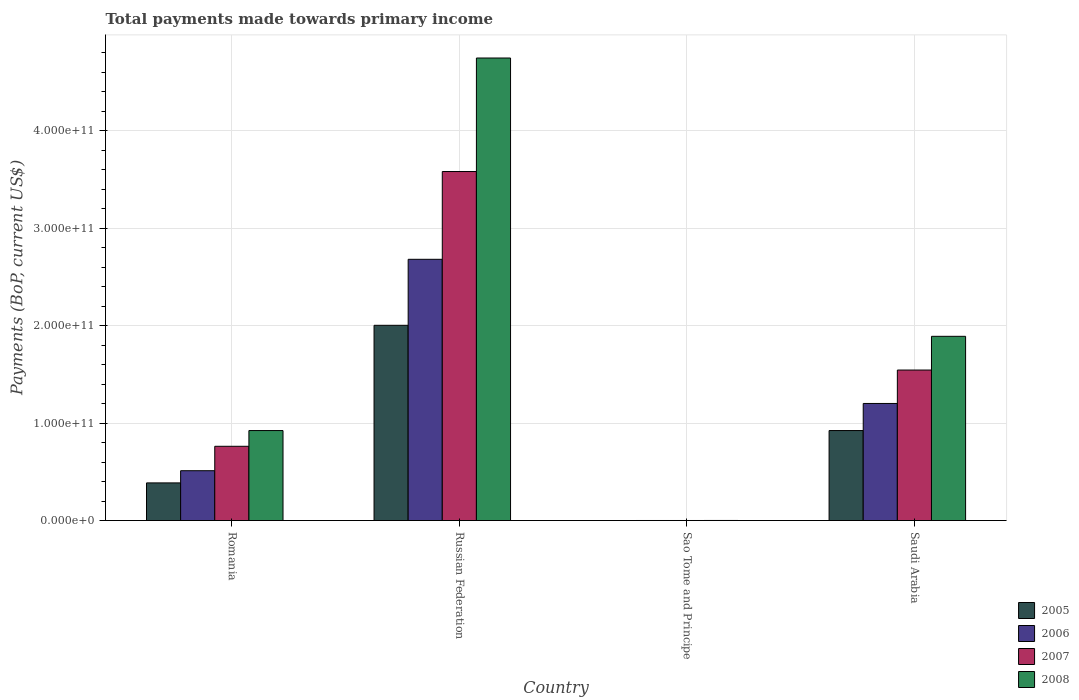Are the number of bars per tick equal to the number of legend labels?
Provide a succinct answer. Yes. Are the number of bars on each tick of the X-axis equal?
Make the answer very short. Yes. What is the label of the 3rd group of bars from the left?
Provide a succinct answer. Sao Tome and Principe. What is the total payments made towards primary income in 2006 in Russian Federation?
Ensure brevity in your answer.  2.68e+11. Across all countries, what is the maximum total payments made towards primary income in 2008?
Keep it short and to the point. 4.75e+11. Across all countries, what is the minimum total payments made towards primary income in 2005?
Your answer should be very brief. 5.76e+07. In which country was the total payments made towards primary income in 2005 maximum?
Your response must be concise. Russian Federation. In which country was the total payments made towards primary income in 2008 minimum?
Make the answer very short. Sao Tome and Principe. What is the total total payments made towards primary income in 2007 in the graph?
Provide a short and direct response. 5.89e+11. What is the difference between the total payments made towards primary income in 2005 in Russian Federation and that in Saudi Arabia?
Give a very brief answer. 1.08e+11. What is the difference between the total payments made towards primary income in 2008 in Sao Tome and Principe and the total payments made towards primary income in 2006 in Russian Federation?
Your answer should be very brief. -2.68e+11. What is the average total payments made towards primary income in 2008 per country?
Your answer should be compact. 1.89e+11. What is the difference between the total payments made towards primary income of/in 2005 and total payments made towards primary income of/in 2008 in Russian Federation?
Your response must be concise. -2.74e+11. In how many countries, is the total payments made towards primary income in 2005 greater than 40000000000 US$?
Your response must be concise. 2. What is the ratio of the total payments made towards primary income in 2005 in Romania to that in Russian Federation?
Provide a succinct answer. 0.19. What is the difference between the highest and the second highest total payments made towards primary income in 2007?
Offer a very short reply. 2.04e+11. What is the difference between the highest and the lowest total payments made towards primary income in 2005?
Keep it short and to the point. 2.00e+11. In how many countries, is the total payments made towards primary income in 2007 greater than the average total payments made towards primary income in 2007 taken over all countries?
Provide a succinct answer. 2. Is the sum of the total payments made towards primary income in 2006 in Romania and Russian Federation greater than the maximum total payments made towards primary income in 2008 across all countries?
Offer a very short reply. No. What does the 2nd bar from the left in Russian Federation represents?
Make the answer very short. 2006. What does the 1st bar from the right in Saudi Arabia represents?
Give a very brief answer. 2008. Is it the case that in every country, the sum of the total payments made towards primary income in 2006 and total payments made towards primary income in 2008 is greater than the total payments made towards primary income in 2005?
Offer a very short reply. Yes. Are all the bars in the graph horizontal?
Provide a succinct answer. No. How many countries are there in the graph?
Your answer should be compact. 4. What is the difference between two consecutive major ticks on the Y-axis?
Ensure brevity in your answer.  1.00e+11. Where does the legend appear in the graph?
Offer a terse response. Bottom right. How many legend labels are there?
Ensure brevity in your answer.  4. How are the legend labels stacked?
Offer a terse response. Vertical. What is the title of the graph?
Keep it short and to the point. Total payments made towards primary income. Does "2004" appear as one of the legend labels in the graph?
Your answer should be compact. No. What is the label or title of the X-axis?
Your answer should be very brief. Country. What is the label or title of the Y-axis?
Keep it short and to the point. Payments (BoP, current US$). What is the Payments (BoP, current US$) of 2005 in Romania?
Offer a terse response. 3.86e+1. What is the Payments (BoP, current US$) of 2006 in Romania?
Your answer should be very brief. 5.11e+1. What is the Payments (BoP, current US$) in 2007 in Romania?
Provide a succinct answer. 7.62e+1. What is the Payments (BoP, current US$) of 2008 in Romania?
Ensure brevity in your answer.  9.23e+1. What is the Payments (BoP, current US$) of 2005 in Russian Federation?
Your answer should be compact. 2.00e+11. What is the Payments (BoP, current US$) of 2006 in Russian Federation?
Provide a succinct answer. 2.68e+11. What is the Payments (BoP, current US$) in 2007 in Russian Federation?
Provide a succinct answer. 3.58e+11. What is the Payments (BoP, current US$) of 2008 in Russian Federation?
Offer a terse response. 4.75e+11. What is the Payments (BoP, current US$) of 2005 in Sao Tome and Principe?
Make the answer very short. 5.76e+07. What is the Payments (BoP, current US$) in 2006 in Sao Tome and Principe?
Make the answer very short. 8.01e+07. What is the Payments (BoP, current US$) in 2007 in Sao Tome and Principe?
Your answer should be compact. 8.58e+07. What is the Payments (BoP, current US$) in 2008 in Sao Tome and Principe?
Your answer should be very brief. 1.16e+08. What is the Payments (BoP, current US$) in 2005 in Saudi Arabia?
Ensure brevity in your answer.  9.23e+1. What is the Payments (BoP, current US$) in 2006 in Saudi Arabia?
Make the answer very short. 1.20e+11. What is the Payments (BoP, current US$) in 2007 in Saudi Arabia?
Your response must be concise. 1.54e+11. What is the Payments (BoP, current US$) of 2008 in Saudi Arabia?
Provide a succinct answer. 1.89e+11. Across all countries, what is the maximum Payments (BoP, current US$) in 2005?
Give a very brief answer. 2.00e+11. Across all countries, what is the maximum Payments (BoP, current US$) of 2006?
Keep it short and to the point. 2.68e+11. Across all countries, what is the maximum Payments (BoP, current US$) of 2007?
Your answer should be compact. 3.58e+11. Across all countries, what is the maximum Payments (BoP, current US$) of 2008?
Offer a very short reply. 4.75e+11. Across all countries, what is the minimum Payments (BoP, current US$) of 2005?
Your answer should be compact. 5.76e+07. Across all countries, what is the minimum Payments (BoP, current US$) in 2006?
Provide a short and direct response. 8.01e+07. Across all countries, what is the minimum Payments (BoP, current US$) in 2007?
Keep it short and to the point. 8.58e+07. Across all countries, what is the minimum Payments (BoP, current US$) in 2008?
Provide a short and direct response. 1.16e+08. What is the total Payments (BoP, current US$) of 2005 in the graph?
Make the answer very short. 3.31e+11. What is the total Payments (BoP, current US$) in 2006 in the graph?
Your answer should be compact. 4.39e+11. What is the total Payments (BoP, current US$) in 2007 in the graph?
Make the answer very short. 5.89e+11. What is the total Payments (BoP, current US$) of 2008 in the graph?
Your answer should be compact. 7.56e+11. What is the difference between the Payments (BoP, current US$) of 2005 in Romania and that in Russian Federation?
Your answer should be very brief. -1.62e+11. What is the difference between the Payments (BoP, current US$) of 2006 in Romania and that in Russian Federation?
Offer a very short reply. -2.17e+11. What is the difference between the Payments (BoP, current US$) in 2007 in Romania and that in Russian Federation?
Your response must be concise. -2.82e+11. What is the difference between the Payments (BoP, current US$) of 2008 in Romania and that in Russian Federation?
Your response must be concise. -3.82e+11. What is the difference between the Payments (BoP, current US$) of 2005 in Romania and that in Sao Tome and Principe?
Give a very brief answer. 3.86e+1. What is the difference between the Payments (BoP, current US$) of 2006 in Romania and that in Sao Tome and Principe?
Make the answer very short. 5.11e+1. What is the difference between the Payments (BoP, current US$) in 2007 in Romania and that in Sao Tome and Principe?
Give a very brief answer. 7.61e+1. What is the difference between the Payments (BoP, current US$) in 2008 in Romania and that in Sao Tome and Principe?
Your answer should be compact. 9.22e+1. What is the difference between the Payments (BoP, current US$) of 2005 in Romania and that in Saudi Arabia?
Offer a very short reply. -5.37e+1. What is the difference between the Payments (BoP, current US$) in 2006 in Romania and that in Saudi Arabia?
Your response must be concise. -6.90e+1. What is the difference between the Payments (BoP, current US$) in 2007 in Romania and that in Saudi Arabia?
Keep it short and to the point. -7.82e+1. What is the difference between the Payments (BoP, current US$) of 2008 in Romania and that in Saudi Arabia?
Keep it short and to the point. -9.67e+1. What is the difference between the Payments (BoP, current US$) of 2005 in Russian Federation and that in Sao Tome and Principe?
Your answer should be very brief. 2.00e+11. What is the difference between the Payments (BoP, current US$) in 2006 in Russian Federation and that in Sao Tome and Principe?
Your response must be concise. 2.68e+11. What is the difference between the Payments (BoP, current US$) in 2007 in Russian Federation and that in Sao Tome and Principe?
Ensure brevity in your answer.  3.58e+11. What is the difference between the Payments (BoP, current US$) in 2008 in Russian Federation and that in Sao Tome and Principe?
Your answer should be compact. 4.74e+11. What is the difference between the Payments (BoP, current US$) in 2005 in Russian Federation and that in Saudi Arabia?
Provide a succinct answer. 1.08e+11. What is the difference between the Payments (BoP, current US$) of 2006 in Russian Federation and that in Saudi Arabia?
Make the answer very short. 1.48e+11. What is the difference between the Payments (BoP, current US$) in 2007 in Russian Federation and that in Saudi Arabia?
Your answer should be very brief. 2.04e+11. What is the difference between the Payments (BoP, current US$) in 2008 in Russian Federation and that in Saudi Arabia?
Your answer should be very brief. 2.86e+11. What is the difference between the Payments (BoP, current US$) of 2005 in Sao Tome and Principe and that in Saudi Arabia?
Your answer should be compact. -9.23e+1. What is the difference between the Payments (BoP, current US$) of 2006 in Sao Tome and Principe and that in Saudi Arabia?
Ensure brevity in your answer.  -1.20e+11. What is the difference between the Payments (BoP, current US$) in 2007 in Sao Tome and Principe and that in Saudi Arabia?
Give a very brief answer. -1.54e+11. What is the difference between the Payments (BoP, current US$) in 2008 in Sao Tome and Principe and that in Saudi Arabia?
Your answer should be compact. -1.89e+11. What is the difference between the Payments (BoP, current US$) of 2005 in Romania and the Payments (BoP, current US$) of 2006 in Russian Federation?
Your response must be concise. -2.29e+11. What is the difference between the Payments (BoP, current US$) of 2005 in Romania and the Payments (BoP, current US$) of 2007 in Russian Federation?
Provide a succinct answer. -3.19e+11. What is the difference between the Payments (BoP, current US$) of 2005 in Romania and the Payments (BoP, current US$) of 2008 in Russian Federation?
Make the answer very short. -4.36e+11. What is the difference between the Payments (BoP, current US$) in 2006 in Romania and the Payments (BoP, current US$) in 2007 in Russian Federation?
Provide a short and direct response. -3.07e+11. What is the difference between the Payments (BoP, current US$) in 2006 in Romania and the Payments (BoP, current US$) in 2008 in Russian Federation?
Your answer should be very brief. -4.23e+11. What is the difference between the Payments (BoP, current US$) of 2007 in Romania and the Payments (BoP, current US$) of 2008 in Russian Federation?
Give a very brief answer. -3.98e+11. What is the difference between the Payments (BoP, current US$) of 2005 in Romania and the Payments (BoP, current US$) of 2006 in Sao Tome and Principe?
Offer a very short reply. 3.86e+1. What is the difference between the Payments (BoP, current US$) of 2005 in Romania and the Payments (BoP, current US$) of 2007 in Sao Tome and Principe?
Provide a short and direct response. 3.86e+1. What is the difference between the Payments (BoP, current US$) of 2005 in Romania and the Payments (BoP, current US$) of 2008 in Sao Tome and Principe?
Provide a succinct answer. 3.85e+1. What is the difference between the Payments (BoP, current US$) in 2006 in Romania and the Payments (BoP, current US$) in 2007 in Sao Tome and Principe?
Keep it short and to the point. 5.11e+1. What is the difference between the Payments (BoP, current US$) of 2006 in Romania and the Payments (BoP, current US$) of 2008 in Sao Tome and Principe?
Your answer should be compact. 5.10e+1. What is the difference between the Payments (BoP, current US$) of 2007 in Romania and the Payments (BoP, current US$) of 2008 in Sao Tome and Principe?
Offer a terse response. 7.61e+1. What is the difference between the Payments (BoP, current US$) of 2005 in Romania and the Payments (BoP, current US$) of 2006 in Saudi Arabia?
Make the answer very short. -8.15e+1. What is the difference between the Payments (BoP, current US$) in 2005 in Romania and the Payments (BoP, current US$) in 2007 in Saudi Arabia?
Ensure brevity in your answer.  -1.16e+11. What is the difference between the Payments (BoP, current US$) of 2005 in Romania and the Payments (BoP, current US$) of 2008 in Saudi Arabia?
Ensure brevity in your answer.  -1.50e+11. What is the difference between the Payments (BoP, current US$) in 2006 in Romania and the Payments (BoP, current US$) in 2007 in Saudi Arabia?
Make the answer very short. -1.03e+11. What is the difference between the Payments (BoP, current US$) of 2006 in Romania and the Payments (BoP, current US$) of 2008 in Saudi Arabia?
Provide a succinct answer. -1.38e+11. What is the difference between the Payments (BoP, current US$) in 2007 in Romania and the Payments (BoP, current US$) in 2008 in Saudi Arabia?
Ensure brevity in your answer.  -1.13e+11. What is the difference between the Payments (BoP, current US$) in 2005 in Russian Federation and the Payments (BoP, current US$) in 2006 in Sao Tome and Principe?
Your answer should be very brief. 2.00e+11. What is the difference between the Payments (BoP, current US$) in 2005 in Russian Federation and the Payments (BoP, current US$) in 2007 in Sao Tome and Principe?
Keep it short and to the point. 2.00e+11. What is the difference between the Payments (BoP, current US$) in 2005 in Russian Federation and the Payments (BoP, current US$) in 2008 in Sao Tome and Principe?
Your response must be concise. 2.00e+11. What is the difference between the Payments (BoP, current US$) of 2006 in Russian Federation and the Payments (BoP, current US$) of 2007 in Sao Tome and Principe?
Your answer should be very brief. 2.68e+11. What is the difference between the Payments (BoP, current US$) of 2006 in Russian Federation and the Payments (BoP, current US$) of 2008 in Sao Tome and Principe?
Keep it short and to the point. 2.68e+11. What is the difference between the Payments (BoP, current US$) of 2007 in Russian Federation and the Payments (BoP, current US$) of 2008 in Sao Tome and Principe?
Your answer should be compact. 3.58e+11. What is the difference between the Payments (BoP, current US$) in 2005 in Russian Federation and the Payments (BoP, current US$) in 2006 in Saudi Arabia?
Offer a very short reply. 8.02e+1. What is the difference between the Payments (BoP, current US$) of 2005 in Russian Federation and the Payments (BoP, current US$) of 2007 in Saudi Arabia?
Make the answer very short. 4.59e+1. What is the difference between the Payments (BoP, current US$) of 2005 in Russian Federation and the Payments (BoP, current US$) of 2008 in Saudi Arabia?
Ensure brevity in your answer.  1.13e+1. What is the difference between the Payments (BoP, current US$) of 2006 in Russian Federation and the Payments (BoP, current US$) of 2007 in Saudi Arabia?
Your answer should be very brief. 1.14e+11. What is the difference between the Payments (BoP, current US$) of 2006 in Russian Federation and the Payments (BoP, current US$) of 2008 in Saudi Arabia?
Offer a terse response. 7.90e+1. What is the difference between the Payments (BoP, current US$) of 2007 in Russian Federation and the Payments (BoP, current US$) of 2008 in Saudi Arabia?
Ensure brevity in your answer.  1.69e+11. What is the difference between the Payments (BoP, current US$) of 2005 in Sao Tome and Principe and the Payments (BoP, current US$) of 2006 in Saudi Arabia?
Make the answer very short. -1.20e+11. What is the difference between the Payments (BoP, current US$) in 2005 in Sao Tome and Principe and the Payments (BoP, current US$) in 2007 in Saudi Arabia?
Provide a short and direct response. -1.54e+11. What is the difference between the Payments (BoP, current US$) in 2005 in Sao Tome and Principe and the Payments (BoP, current US$) in 2008 in Saudi Arabia?
Your answer should be very brief. -1.89e+11. What is the difference between the Payments (BoP, current US$) of 2006 in Sao Tome and Principe and the Payments (BoP, current US$) of 2007 in Saudi Arabia?
Offer a very short reply. -1.54e+11. What is the difference between the Payments (BoP, current US$) in 2006 in Sao Tome and Principe and the Payments (BoP, current US$) in 2008 in Saudi Arabia?
Offer a terse response. -1.89e+11. What is the difference between the Payments (BoP, current US$) of 2007 in Sao Tome and Principe and the Payments (BoP, current US$) of 2008 in Saudi Arabia?
Offer a very short reply. -1.89e+11. What is the average Payments (BoP, current US$) in 2005 per country?
Offer a terse response. 8.28e+1. What is the average Payments (BoP, current US$) of 2006 per country?
Make the answer very short. 1.10e+11. What is the average Payments (BoP, current US$) of 2007 per country?
Your response must be concise. 1.47e+11. What is the average Payments (BoP, current US$) of 2008 per country?
Give a very brief answer. 1.89e+11. What is the difference between the Payments (BoP, current US$) of 2005 and Payments (BoP, current US$) of 2006 in Romania?
Your answer should be very brief. -1.25e+1. What is the difference between the Payments (BoP, current US$) of 2005 and Payments (BoP, current US$) of 2007 in Romania?
Give a very brief answer. -3.76e+1. What is the difference between the Payments (BoP, current US$) in 2005 and Payments (BoP, current US$) in 2008 in Romania?
Give a very brief answer. -5.37e+1. What is the difference between the Payments (BoP, current US$) of 2006 and Payments (BoP, current US$) of 2007 in Romania?
Give a very brief answer. -2.51e+1. What is the difference between the Payments (BoP, current US$) in 2006 and Payments (BoP, current US$) in 2008 in Romania?
Keep it short and to the point. -4.12e+1. What is the difference between the Payments (BoP, current US$) in 2007 and Payments (BoP, current US$) in 2008 in Romania?
Offer a very short reply. -1.61e+1. What is the difference between the Payments (BoP, current US$) of 2005 and Payments (BoP, current US$) of 2006 in Russian Federation?
Offer a terse response. -6.77e+1. What is the difference between the Payments (BoP, current US$) in 2005 and Payments (BoP, current US$) in 2007 in Russian Federation?
Your answer should be compact. -1.58e+11. What is the difference between the Payments (BoP, current US$) in 2005 and Payments (BoP, current US$) in 2008 in Russian Federation?
Give a very brief answer. -2.74e+11. What is the difference between the Payments (BoP, current US$) of 2006 and Payments (BoP, current US$) of 2007 in Russian Federation?
Ensure brevity in your answer.  -9.00e+1. What is the difference between the Payments (BoP, current US$) in 2006 and Payments (BoP, current US$) in 2008 in Russian Federation?
Make the answer very short. -2.06e+11. What is the difference between the Payments (BoP, current US$) in 2007 and Payments (BoP, current US$) in 2008 in Russian Federation?
Your answer should be very brief. -1.16e+11. What is the difference between the Payments (BoP, current US$) of 2005 and Payments (BoP, current US$) of 2006 in Sao Tome and Principe?
Provide a succinct answer. -2.26e+07. What is the difference between the Payments (BoP, current US$) of 2005 and Payments (BoP, current US$) of 2007 in Sao Tome and Principe?
Provide a succinct answer. -2.83e+07. What is the difference between the Payments (BoP, current US$) of 2005 and Payments (BoP, current US$) of 2008 in Sao Tome and Principe?
Offer a very short reply. -5.80e+07. What is the difference between the Payments (BoP, current US$) of 2006 and Payments (BoP, current US$) of 2007 in Sao Tome and Principe?
Ensure brevity in your answer.  -5.70e+06. What is the difference between the Payments (BoP, current US$) in 2006 and Payments (BoP, current US$) in 2008 in Sao Tome and Principe?
Ensure brevity in your answer.  -3.55e+07. What is the difference between the Payments (BoP, current US$) of 2007 and Payments (BoP, current US$) of 2008 in Sao Tome and Principe?
Offer a terse response. -2.98e+07. What is the difference between the Payments (BoP, current US$) in 2005 and Payments (BoP, current US$) in 2006 in Saudi Arabia?
Your answer should be very brief. -2.78e+1. What is the difference between the Payments (BoP, current US$) of 2005 and Payments (BoP, current US$) of 2007 in Saudi Arabia?
Give a very brief answer. -6.21e+1. What is the difference between the Payments (BoP, current US$) in 2005 and Payments (BoP, current US$) in 2008 in Saudi Arabia?
Provide a succinct answer. -9.67e+1. What is the difference between the Payments (BoP, current US$) of 2006 and Payments (BoP, current US$) of 2007 in Saudi Arabia?
Provide a succinct answer. -3.43e+1. What is the difference between the Payments (BoP, current US$) in 2006 and Payments (BoP, current US$) in 2008 in Saudi Arabia?
Your response must be concise. -6.89e+1. What is the difference between the Payments (BoP, current US$) of 2007 and Payments (BoP, current US$) of 2008 in Saudi Arabia?
Your response must be concise. -3.46e+1. What is the ratio of the Payments (BoP, current US$) in 2005 in Romania to that in Russian Federation?
Give a very brief answer. 0.19. What is the ratio of the Payments (BoP, current US$) of 2006 in Romania to that in Russian Federation?
Offer a very short reply. 0.19. What is the ratio of the Payments (BoP, current US$) of 2007 in Romania to that in Russian Federation?
Ensure brevity in your answer.  0.21. What is the ratio of the Payments (BoP, current US$) in 2008 in Romania to that in Russian Federation?
Provide a short and direct response. 0.19. What is the ratio of the Payments (BoP, current US$) in 2005 in Romania to that in Sao Tome and Principe?
Make the answer very short. 671.38. What is the ratio of the Payments (BoP, current US$) of 2006 in Romania to that in Sao Tome and Principe?
Offer a very short reply. 638.39. What is the ratio of the Payments (BoP, current US$) of 2007 in Romania to that in Sao Tome and Principe?
Give a very brief answer. 887.93. What is the ratio of the Payments (BoP, current US$) of 2008 in Romania to that in Sao Tome and Principe?
Offer a very short reply. 798.79. What is the ratio of the Payments (BoP, current US$) in 2005 in Romania to that in Saudi Arabia?
Provide a short and direct response. 0.42. What is the ratio of the Payments (BoP, current US$) in 2006 in Romania to that in Saudi Arabia?
Offer a terse response. 0.43. What is the ratio of the Payments (BoP, current US$) in 2007 in Romania to that in Saudi Arabia?
Offer a terse response. 0.49. What is the ratio of the Payments (BoP, current US$) in 2008 in Romania to that in Saudi Arabia?
Give a very brief answer. 0.49. What is the ratio of the Payments (BoP, current US$) in 2005 in Russian Federation to that in Sao Tome and Principe?
Your response must be concise. 3480.06. What is the ratio of the Payments (BoP, current US$) of 2006 in Russian Federation to that in Sao Tome and Principe?
Your answer should be compact. 3345.24. What is the ratio of the Payments (BoP, current US$) of 2007 in Russian Federation to that in Sao Tome and Principe?
Your answer should be very brief. 4172.13. What is the ratio of the Payments (BoP, current US$) in 2008 in Russian Federation to that in Sao Tome and Principe?
Ensure brevity in your answer.  4104.81. What is the ratio of the Payments (BoP, current US$) of 2005 in Russian Federation to that in Saudi Arabia?
Your answer should be very brief. 2.17. What is the ratio of the Payments (BoP, current US$) in 2006 in Russian Federation to that in Saudi Arabia?
Offer a very short reply. 2.23. What is the ratio of the Payments (BoP, current US$) of 2007 in Russian Federation to that in Saudi Arabia?
Provide a short and direct response. 2.32. What is the ratio of the Payments (BoP, current US$) of 2008 in Russian Federation to that in Saudi Arabia?
Offer a terse response. 2.51. What is the ratio of the Payments (BoP, current US$) of 2005 in Sao Tome and Principe to that in Saudi Arabia?
Make the answer very short. 0. What is the ratio of the Payments (BoP, current US$) in 2006 in Sao Tome and Principe to that in Saudi Arabia?
Give a very brief answer. 0. What is the ratio of the Payments (BoP, current US$) in 2007 in Sao Tome and Principe to that in Saudi Arabia?
Your answer should be compact. 0. What is the ratio of the Payments (BoP, current US$) of 2008 in Sao Tome and Principe to that in Saudi Arabia?
Offer a very short reply. 0. What is the difference between the highest and the second highest Payments (BoP, current US$) of 2005?
Keep it short and to the point. 1.08e+11. What is the difference between the highest and the second highest Payments (BoP, current US$) of 2006?
Offer a terse response. 1.48e+11. What is the difference between the highest and the second highest Payments (BoP, current US$) of 2007?
Make the answer very short. 2.04e+11. What is the difference between the highest and the second highest Payments (BoP, current US$) of 2008?
Provide a succinct answer. 2.86e+11. What is the difference between the highest and the lowest Payments (BoP, current US$) of 2005?
Your answer should be very brief. 2.00e+11. What is the difference between the highest and the lowest Payments (BoP, current US$) in 2006?
Your response must be concise. 2.68e+11. What is the difference between the highest and the lowest Payments (BoP, current US$) in 2007?
Offer a very short reply. 3.58e+11. What is the difference between the highest and the lowest Payments (BoP, current US$) in 2008?
Your answer should be compact. 4.74e+11. 